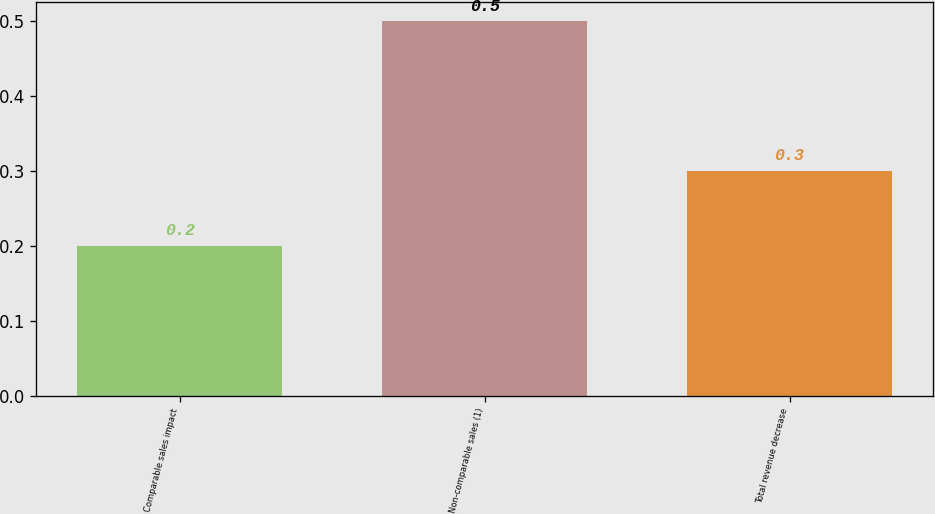<chart> <loc_0><loc_0><loc_500><loc_500><bar_chart><fcel>Comparable sales impact<fcel>Non-comparable sales (1)<fcel>Total revenue decrease<nl><fcel>0.2<fcel>0.5<fcel>0.3<nl></chart> 